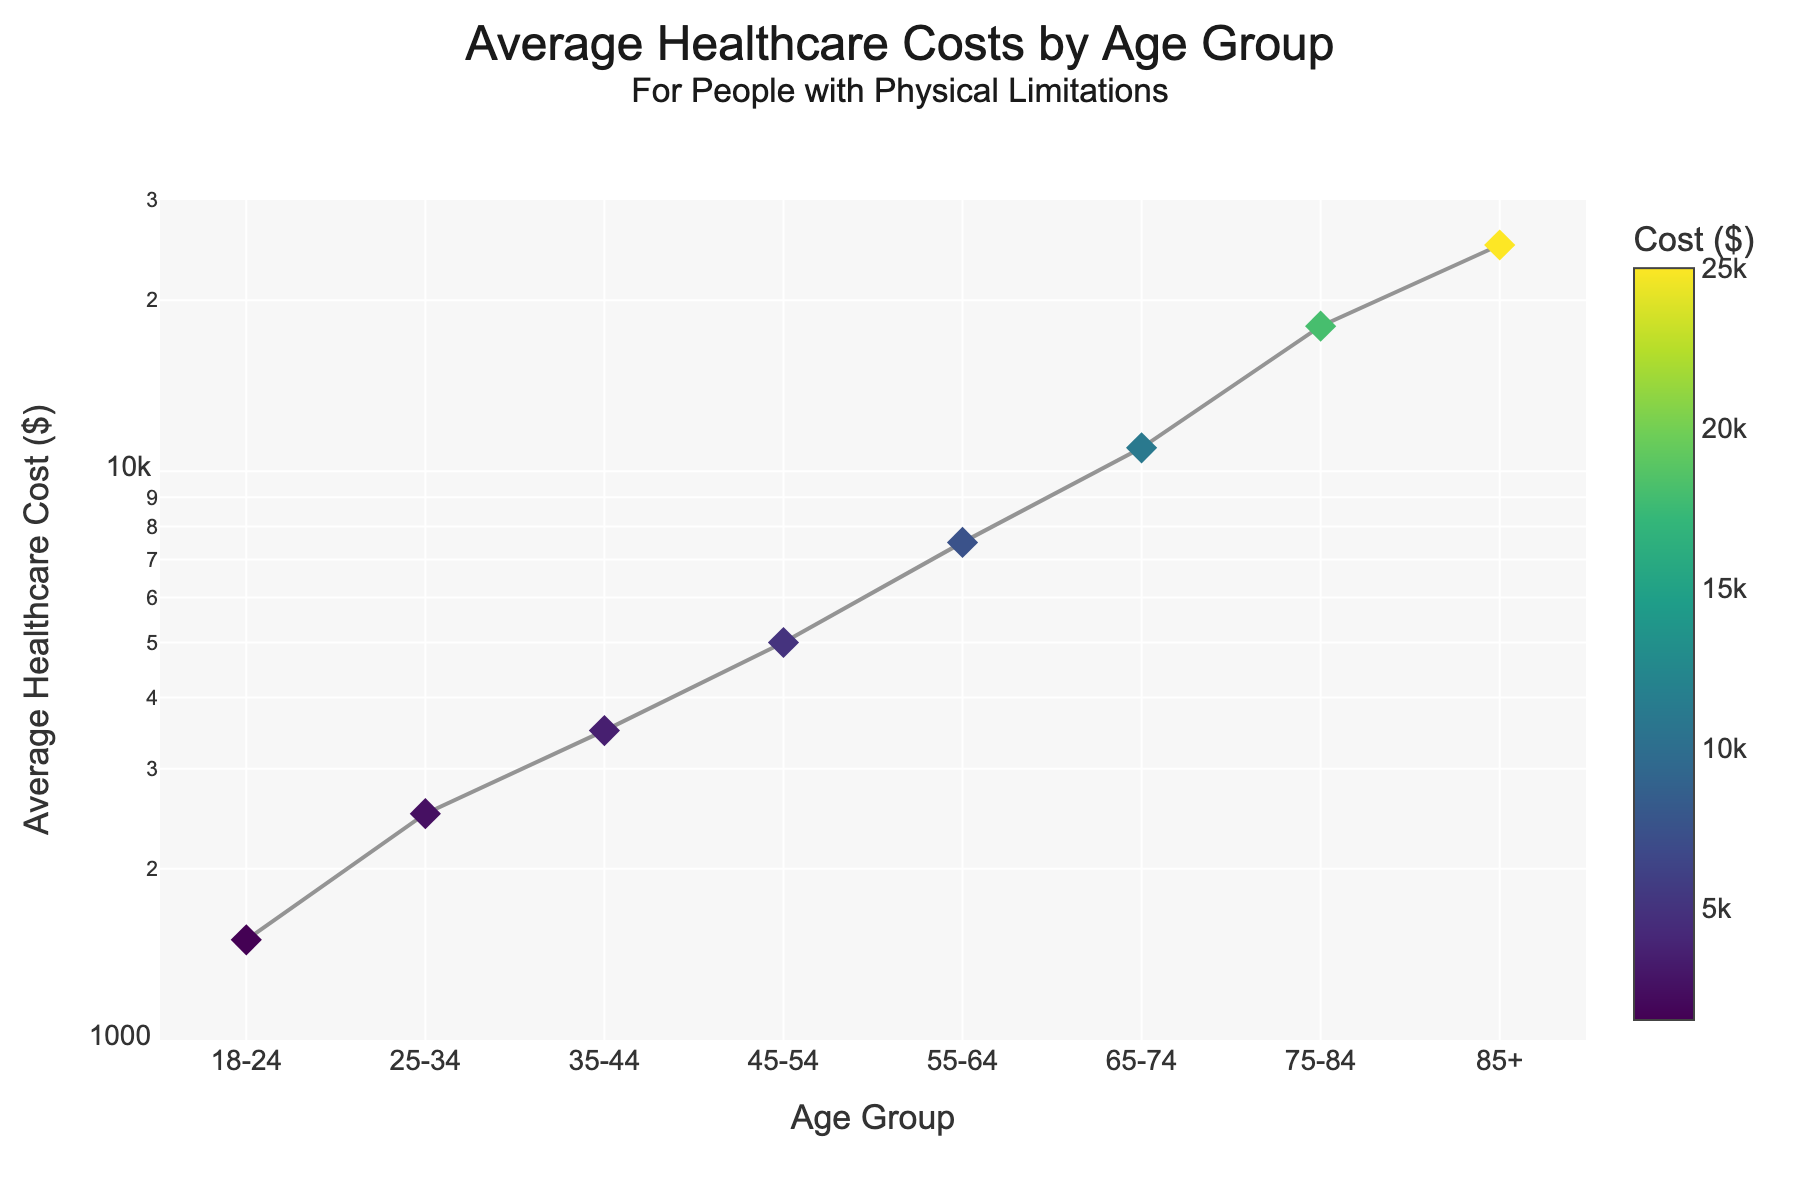What's the title of the scatter plot? The title is often found at the top of the figure and helps provide an overall overview of the data being presented. In this case, the title includes "Average Healthcare Costs by Age Group" followed by a subtitle "For People with Physical Limitations".
Answer: Average Healthcare Costs by Age Group for People with Physical Limitations Which age group has the highest average healthcare cost? To find out which age group has the highest average healthcare cost, look at the vertical positions of the points. The point at the highest position on the y-axis represents the highest healthcare cost. The highest point corresponds to the age group "85+".
Answer: 85+ What pattern do you observe in healthcare costs as age increases? To determine the pattern, observe the general trend of the points from left to right along the x-axis. The points form a line that rises as you move right, indicating that healthcare costs increase with age.
Answer: Healthcare costs increase with age By how much does the average healthcare cost increase from the "18-24" age group to the "65-74" age group? Identify the healthcare costs for the "18-24" and "65-74" age groups on the y-axis, which are $1500 and $11000, respectively. Subtract the first value from the second: $11000 - $1500.
Answer: $9500 Which age group shows an average healthcare cost of around $7500? Locate the point near the $7500 mark on the y-axis and trace it horizontally to the x-axis. The corresponding age group is "55-64".
Answer: 55-64 Compare the healthcare cost increase between two consecutive age groups: "25-34" and "35-44". Identify the healthcare costs for "25-34" ($2500) and "35-44" ($3500). Subtract the cost of "25-34" from "35-44": $3500 - $2500.
Answer: $1000 What does the color scale represent in the scatter plot? The color scale represents the average healthcare costs. Points with different colors correspond to different cost amounts, with the color bar on the right indicating the mapping from color to cost.
Answer: Average healthcare costs Why is the y-axis in a log scale for this scatter plot? A logarithmic scale is useful when data spans several orders of magnitude, making it easier to visualize differences and trends across a wide range of values. Here, healthcare costs range from $1500 to $25000, which would be difficult to plot linearly.
Answer: To visualize costs spanning multiple orders of magnitude What is the approximate average healthcare cost for the "75-84" age group? Look for the point corresponding to "75-84" on the x-axis and trace it upward to read the y-axis value. The average healthcare cost is close to $18000.
Answer: $18000 